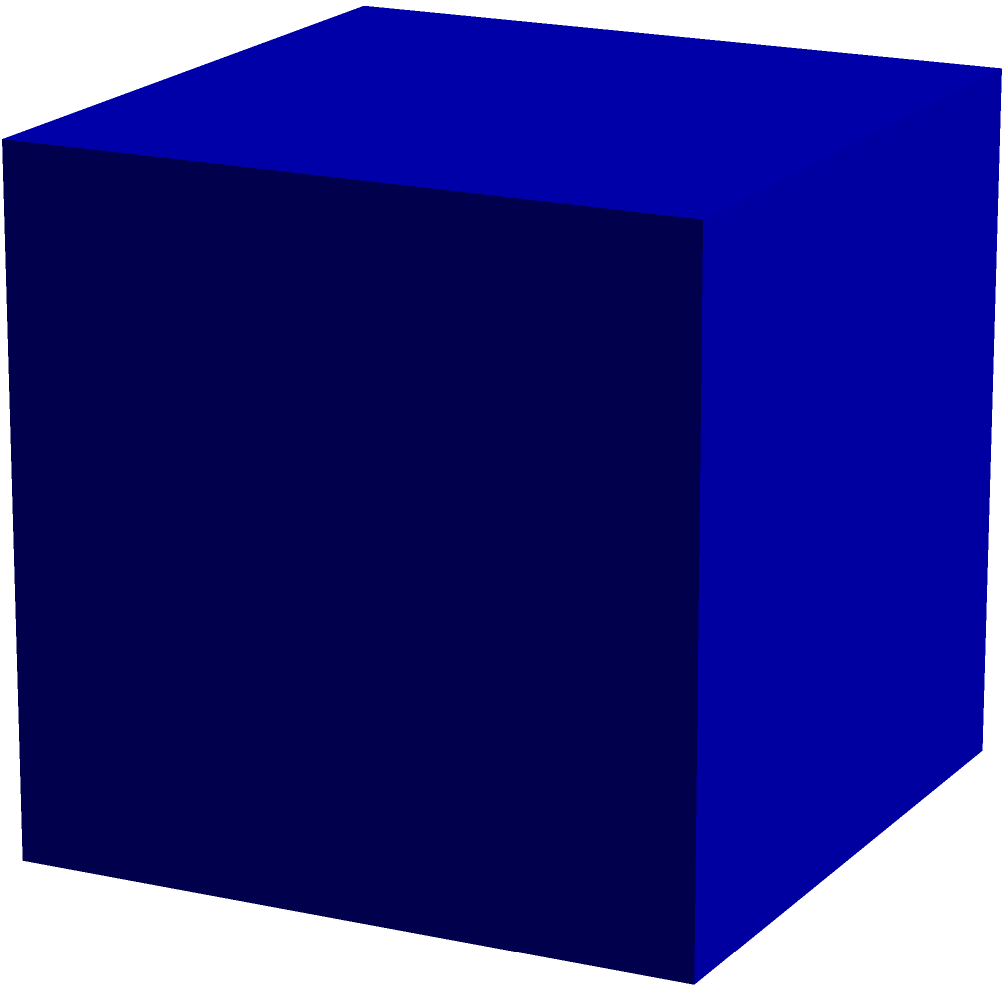Your company is designing a new AI server rack with a cuboid shape. The dimensions are 80 cm in width, 60 cm in depth, and 120 cm in height. To optimize cooling efficiency, you need to calculate the total surface area of the rack. What is the surface area in square meters? To calculate the surface area of a cuboid, we need to sum the areas of all six faces. Let's break it down step-by-step:

1. Convert dimensions to meters:
   Width (w) = 80 cm = 0.8 m
   Depth (d) = 60 cm = 0.6 m
   Height (h) = 120 cm = 1.2 m

2. Calculate the area of each pair of faces:
   - Front and back: $A_1 = 2 \times (w \times h) = 2 \times (0.8 \times 1.2) = 1.92$ m²
   - Left and right: $A_2 = 2 \times (d \times h) = 2 \times (0.6 \times 1.2) = 1.44$ m²
   - Top and bottom: $A_3 = 2 \times (w \times d) = 2 \times (0.8 \times 0.6) = 0.96$ m²

3. Sum up all the areas:
   Total surface area = $A_1 + A_2 + A_3 = 1.92 + 1.44 + 0.96 = 4.32$ m²

Therefore, the total surface area of the AI server rack is 4.32 square meters.
Answer: 4.32 m² 